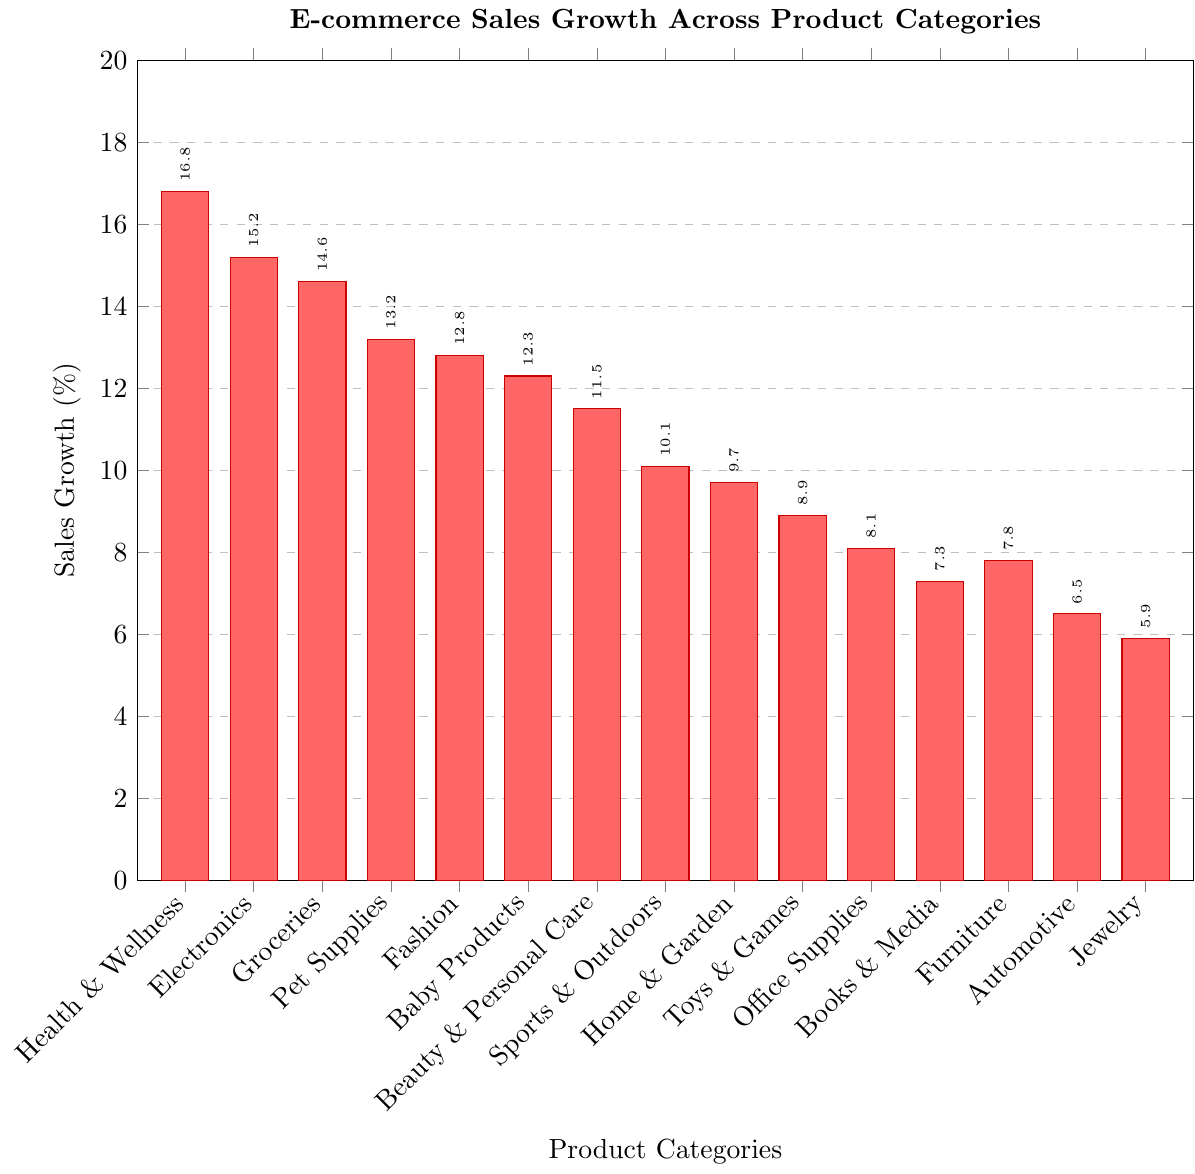What's the category with the highest sales growth? The highest bar represents the category with the highest sales growth. Look for the tallest bar. The tallest bar corresponds to "Health & Wellness" with a height of 16.8%.
Answer: Health & Wellness Which category has the lowest sales growth? The shortest bar represents the category with the lowest sales growth. Locate the shortest bar. The shortest bar corresponds to "Jewelry" with a height of 5.9%.
Answer: Jewelry What is the combined sales growth percentage of the top three categories? Identify the top three categories by looking at the three tallest bars: Health & Wellness (16.8%), Electronics (15.2%), and Groceries (14.6%). Sum their growth percentages: 16.8 + 15.2 + 14.6 = 46.6%.
Answer: 46.6% How much higher is the sales growth of Electronics compared to Jewelry? Determine the growth percentages of Electronics (15.2%) and Jewelry (5.9%). Subtract the smaller percentage from the larger one: 15.2 - 5.9 = 9.3%.
Answer: 9.3% What is the average sales growth across all categories? Sum the growth percentages of all 15 categories and divide by the number of categories. The percentages are: 16.8, 15.2, 14.6, 13.2, 12.8, 12.3, 11.5, 10.1, 9.7, 8.9, 8.1, 7.3, 7.8, 6.5, 5.9. The total sum is 160.7. Divide by 15: 160.7 / 15 ≈ 10.71%.
Answer: 10.71% Which categories have a sales growth percentage greater than 10%? Identify bars with heights above 10%. The categories are: Health & Wellness (16.8%), Electronics (15.2%), Groceries (14.6%), Pet Supplies (13.2%), Fashion (12.8%), Baby Products (12.3%), Beauty & Personal Care (11.5%), and Sports & Outdoors (10.1%).
Answer: Health & Wellness, Electronics, Groceries, Pet Supplies, Fashion, Baby Products, Beauty & Personal Care, Sports & Outdoors Between Home & Garden and Office Supplies, which has a higher sales growth and by how much? Locate the bars for Home & Garden (9.7%) and Office Supplies (8.1%). Subtract the smaller value from the larger: 9.7 - 8.1 = 1.6%.
Answer: Home & Garden, 1.6% What is the median sales growth percentage of all the categories? List all the sales growth percentages in ascending order and find the middle value: 5.9, 6.5, 7.3, 7.8, 8.1, 8.9, 9.7, 10.1, 11.5, 12.3, 12.8, 13.2, 14.6, 15.2, 16.8. The middle value (8th position) is 10.1%.
Answer: 10.1% How much more is the average sales growth of the top five categories compared to the bottom five categories? List the top five percentages: 16.8, 15.2, 14.6, 13.2, 12.8. Their average is (16.8 + 15.2 + 14.6 + 13.2 + 12.8) / 5 = 72.6 / 5 = 14.52%. List the bottom five percentages: 5.9, 6.5, 7.3, 7.8, 8.1. Their average is (5.9 + 6.5 + 7.3 + 7.8 + 8.1) / 5 = 35.6 / 5 = 7.12%. The difference is 14.52 - 7.12 = 7.4%.
Answer: 7.4% Which color bar represents the category with the second highest sales growth? The second highest bar, which is Electronics (15.2%), is the second tallest. The color of this bar, based on the cycle, is red.
Answer: Red 